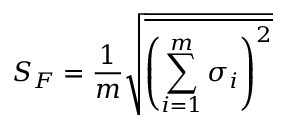Convert formula to latex. <formula><loc_0><loc_0><loc_500><loc_500>S _ { F } = \frac { 1 } { m } \sqrt { \overline { { { \left ( \sum _ { i = 1 } ^ { m } \sigma _ { i } \right ) } ^ { 2 } } } }</formula> 